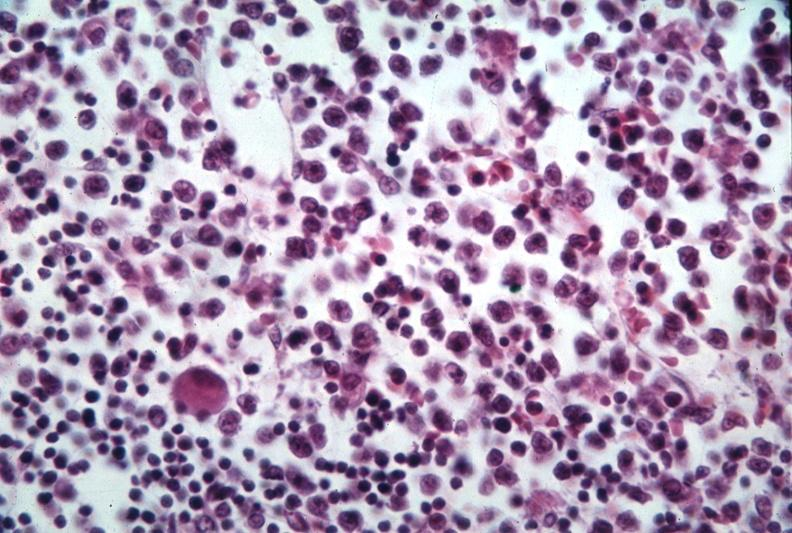s bone marrow present?
Answer the question using a single word or phrase. Yes 